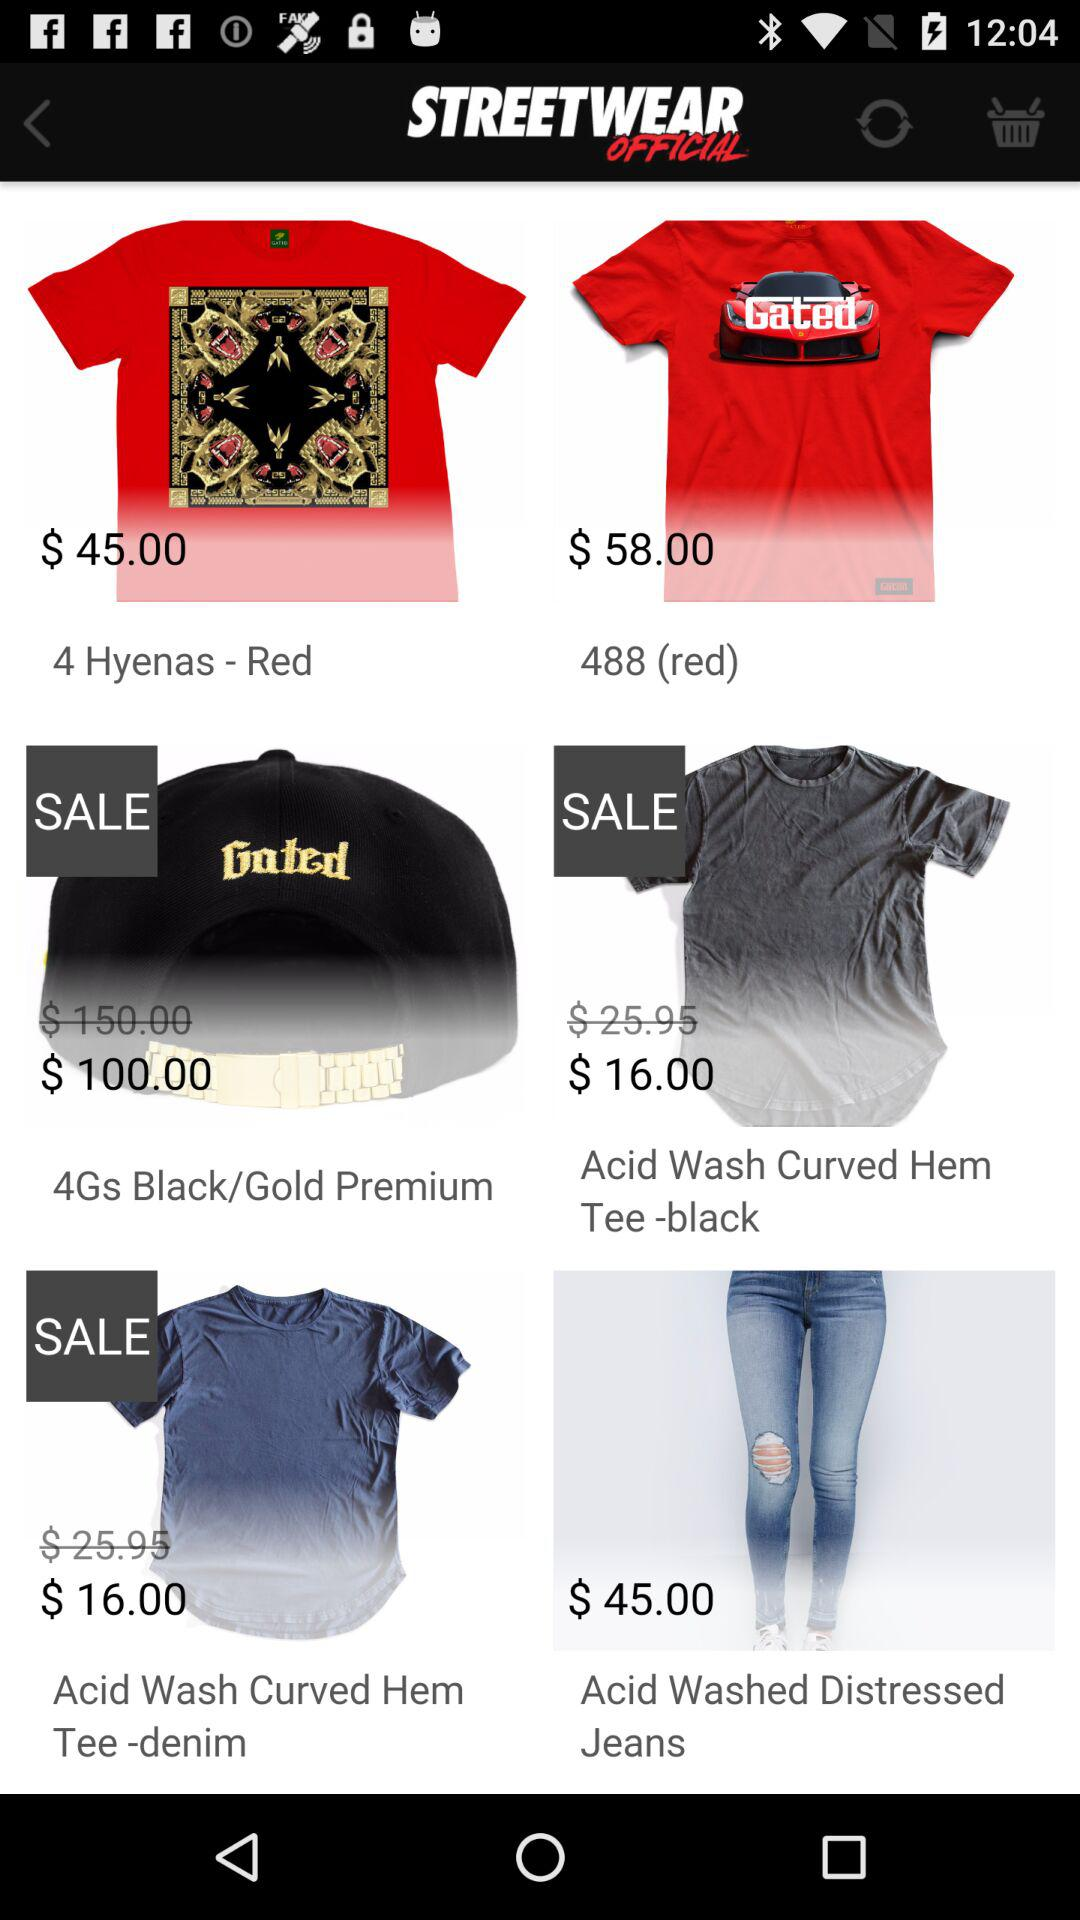What item has a price of $100? The item is "4Gs Black/Gold Premium". 